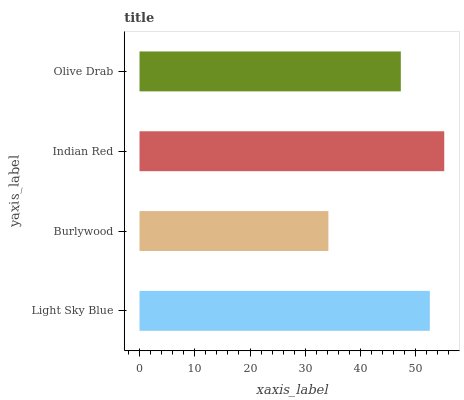Is Burlywood the minimum?
Answer yes or no. Yes. Is Indian Red the maximum?
Answer yes or no. Yes. Is Indian Red the minimum?
Answer yes or no. No. Is Burlywood the maximum?
Answer yes or no. No. Is Indian Red greater than Burlywood?
Answer yes or no. Yes. Is Burlywood less than Indian Red?
Answer yes or no. Yes. Is Burlywood greater than Indian Red?
Answer yes or no. No. Is Indian Red less than Burlywood?
Answer yes or no. No. Is Light Sky Blue the high median?
Answer yes or no. Yes. Is Olive Drab the low median?
Answer yes or no. Yes. Is Burlywood the high median?
Answer yes or no. No. Is Light Sky Blue the low median?
Answer yes or no. No. 